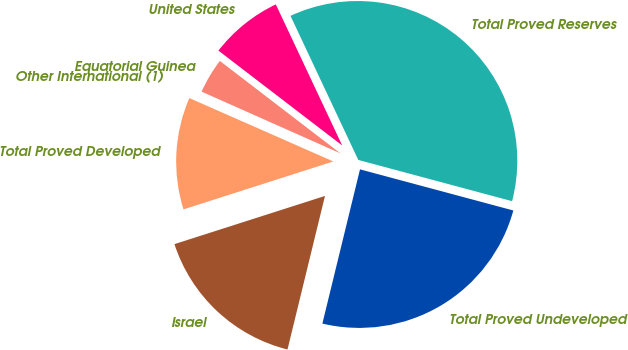<chart> <loc_0><loc_0><loc_500><loc_500><pie_chart><fcel>United States<fcel>Equatorial Guinea<fcel>Other International (1)<fcel>Total Proved Developed<fcel>Israel<fcel>Total Proved Undeveloped<fcel>Total Proved Reserves<nl><fcel>7.59%<fcel>3.75%<fcel>0.06%<fcel>11.53%<fcel>16.26%<fcel>24.64%<fcel>36.17%<nl></chart> 